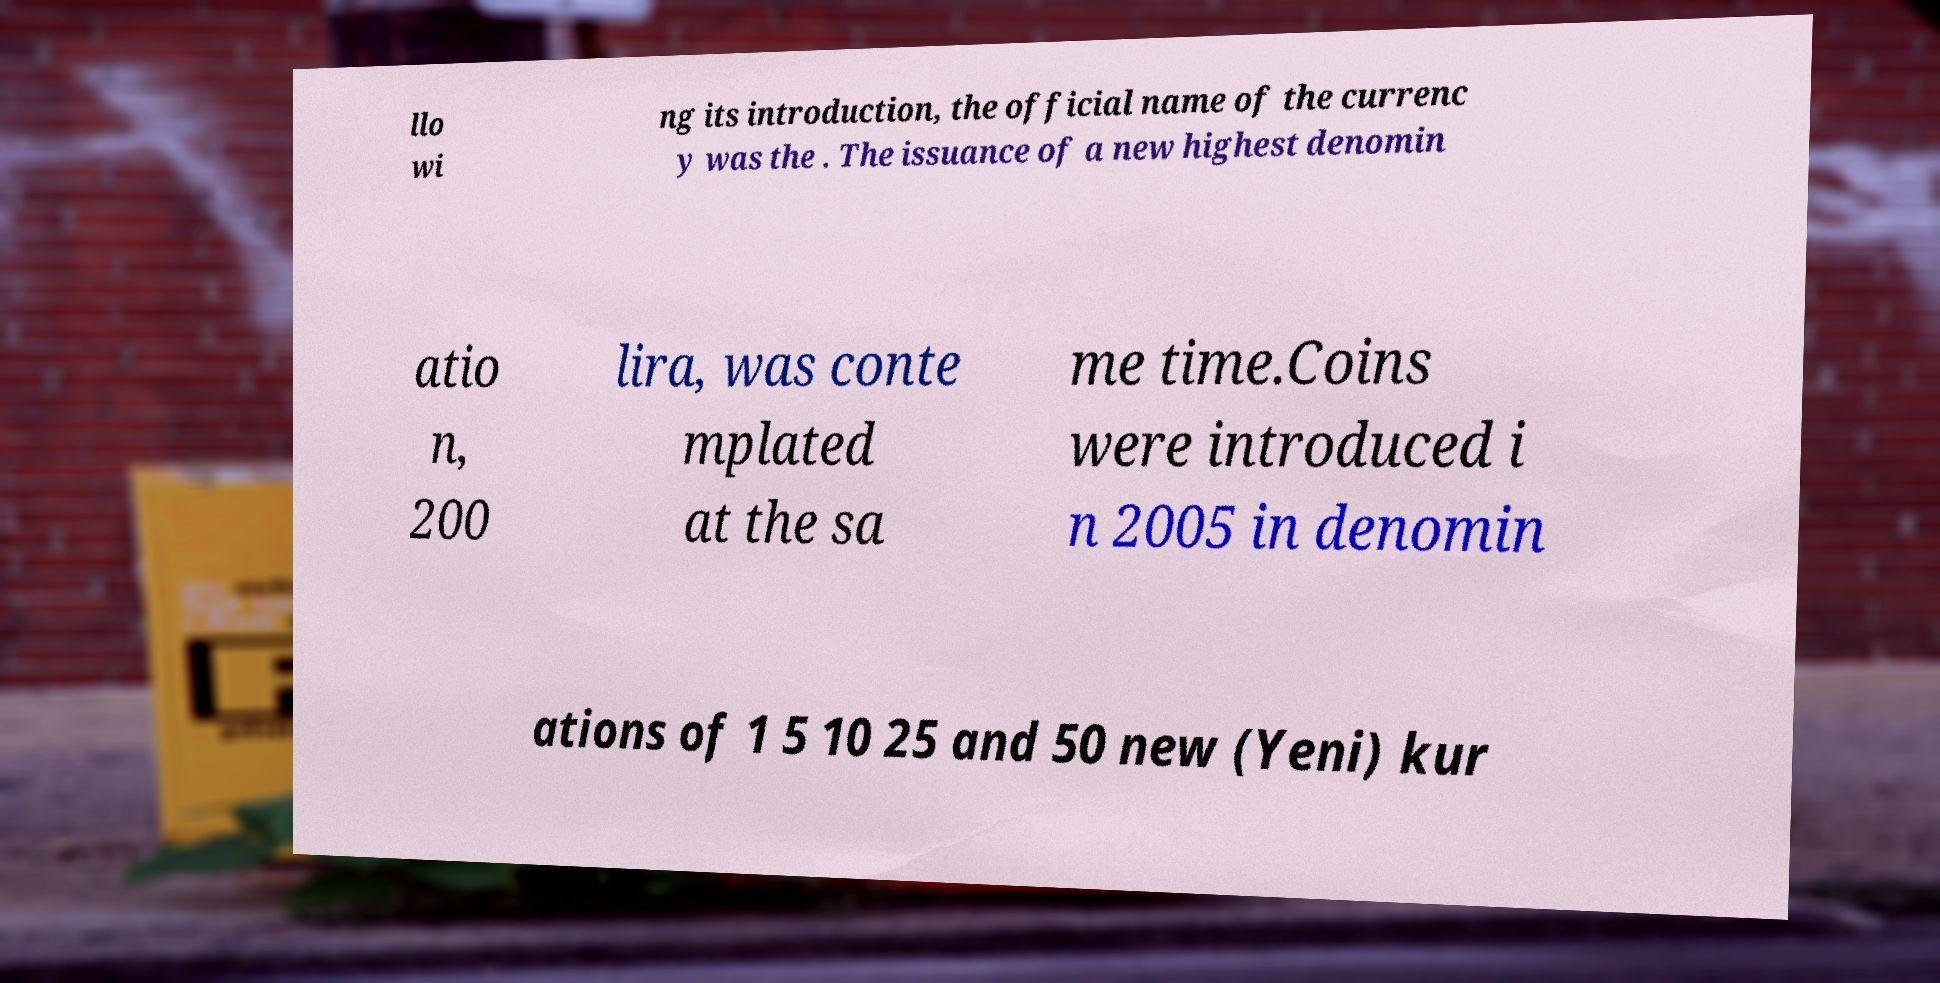For documentation purposes, I need the text within this image transcribed. Could you provide that? llo wi ng its introduction, the official name of the currenc y was the . The issuance of a new highest denomin atio n, 200 lira, was conte mplated at the sa me time.Coins were introduced i n 2005 in denomin ations of 1 5 10 25 and 50 new (Yeni) kur 